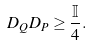Convert formula to latex. <formula><loc_0><loc_0><loc_500><loc_500>D _ { Q } D _ { P } \geq \frac { \mathbb { I } } { 4 } .</formula> 